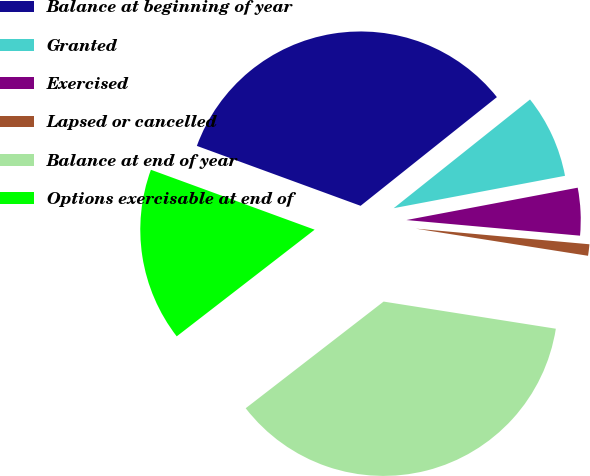Convert chart to OTSL. <chart><loc_0><loc_0><loc_500><loc_500><pie_chart><fcel>Balance at beginning of year<fcel>Granted<fcel>Exercised<fcel>Lapsed or cancelled<fcel>Balance at end of year<fcel>Options exercisable at end of<nl><fcel>33.7%<fcel>7.74%<fcel>4.4%<fcel>1.06%<fcel>37.03%<fcel>16.06%<nl></chart> 